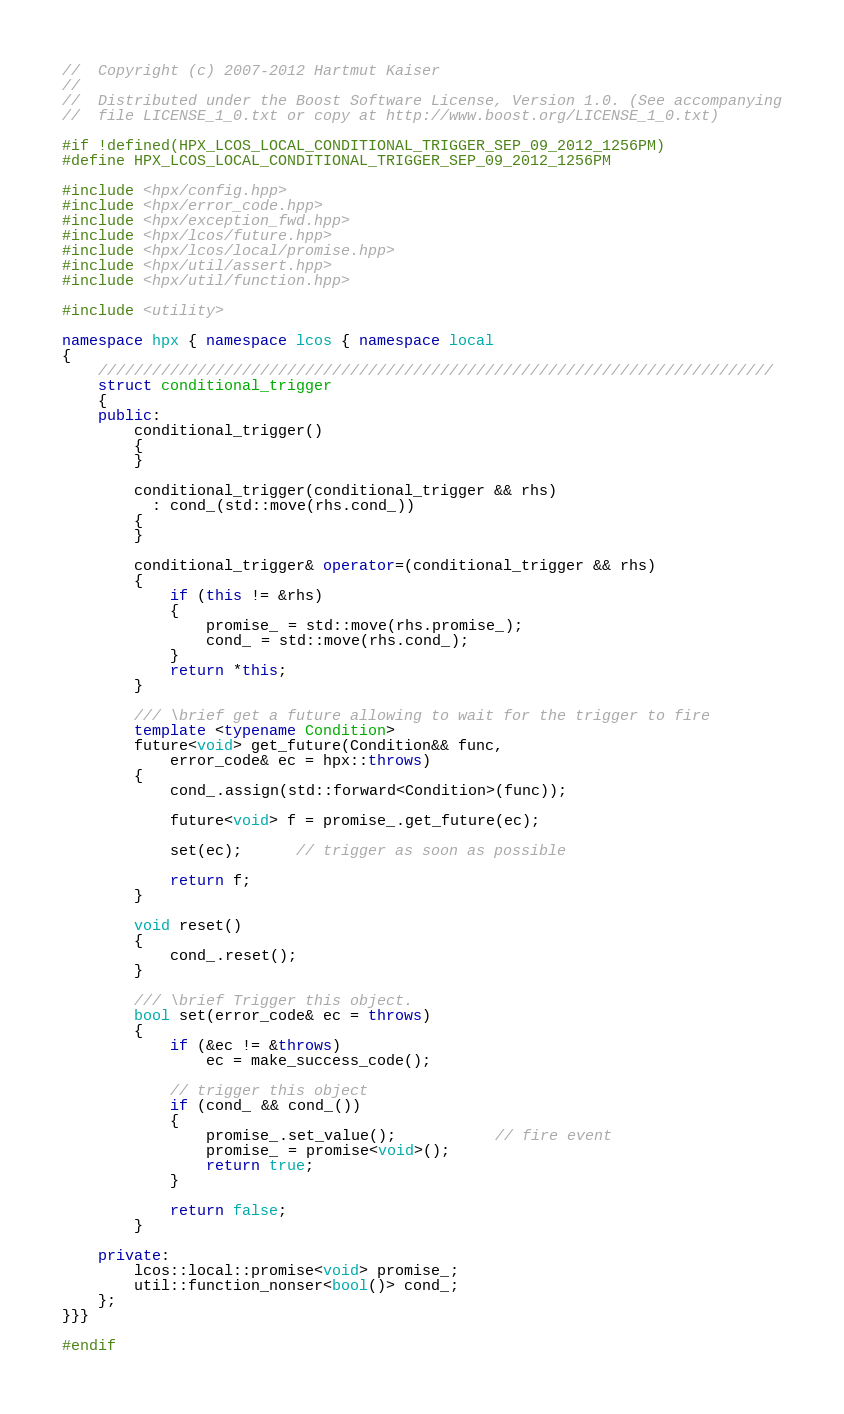Convert code to text. <code><loc_0><loc_0><loc_500><loc_500><_C++_>//  Copyright (c) 2007-2012 Hartmut Kaiser
//
//  Distributed under the Boost Software License, Version 1.0. (See accompanying
//  file LICENSE_1_0.txt or copy at http://www.boost.org/LICENSE_1_0.txt)

#if !defined(HPX_LCOS_LOCAL_CONDITIONAL_TRIGGER_SEP_09_2012_1256PM)
#define HPX_LCOS_LOCAL_CONDITIONAL_TRIGGER_SEP_09_2012_1256PM

#include <hpx/config.hpp>
#include <hpx/error_code.hpp>
#include <hpx/exception_fwd.hpp>
#include <hpx/lcos/future.hpp>
#include <hpx/lcos/local/promise.hpp>
#include <hpx/util/assert.hpp>
#include <hpx/util/function.hpp>

#include <utility>

namespace hpx { namespace lcos { namespace local
{
    ///////////////////////////////////////////////////////////////////////////
    struct conditional_trigger
    {
    public:
        conditional_trigger()
        {
        }

        conditional_trigger(conditional_trigger && rhs)
          : cond_(std::move(rhs.cond_))
        {
        }

        conditional_trigger& operator=(conditional_trigger && rhs)
        {
            if (this != &rhs)
            {
                promise_ = std::move(rhs.promise_);
                cond_ = std::move(rhs.cond_);
            }
            return *this;
        }

        /// \brief get a future allowing to wait for the trigger to fire
        template <typename Condition>
        future<void> get_future(Condition&& func,
            error_code& ec = hpx::throws)
        {
            cond_.assign(std::forward<Condition>(func));

            future<void> f = promise_.get_future(ec);

            set(ec);      // trigger as soon as possible

            return f;
        }

        void reset()
        {
            cond_.reset();
        }

        /// \brief Trigger this object.
        bool set(error_code& ec = throws)
        {
            if (&ec != &throws)
                ec = make_success_code();

            // trigger this object
            if (cond_ && cond_())
            {
                promise_.set_value();           // fire event
                promise_ = promise<void>();
                return true;
            }

            return false;
        }

    private:
        lcos::local::promise<void> promise_;
        util::function_nonser<bool()> cond_;
    };
}}}

#endif
</code> 